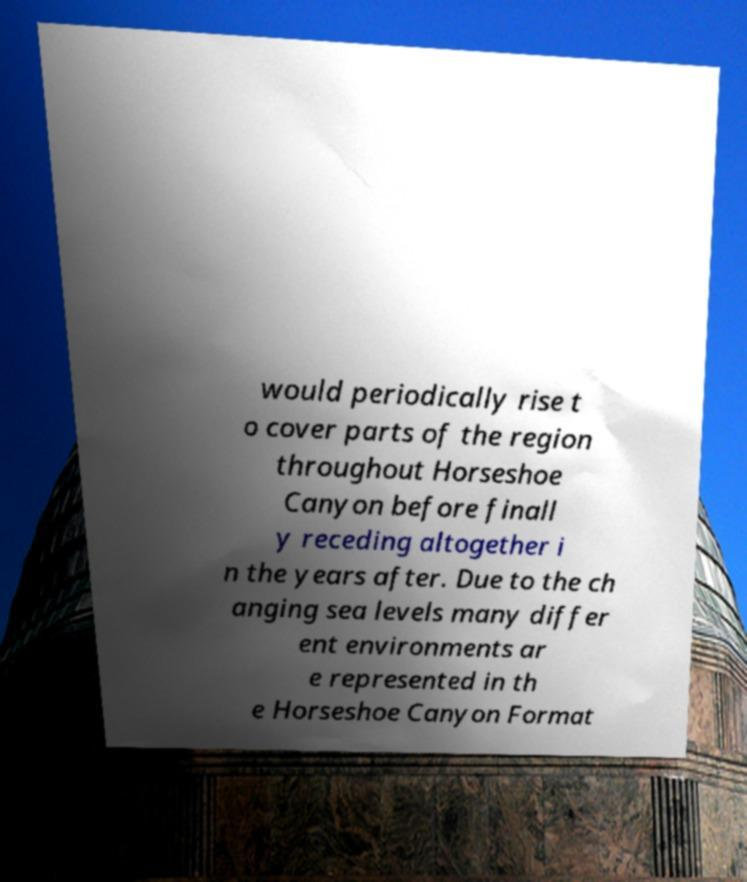What messages or text are displayed in this image? I need them in a readable, typed format. would periodically rise t o cover parts of the region throughout Horseshoe Canyon before finall y receding altogether i n the years after. Due to the ch anging sea levels many differ ent environments ar e represented in th e Horseshoe Canyon Format 